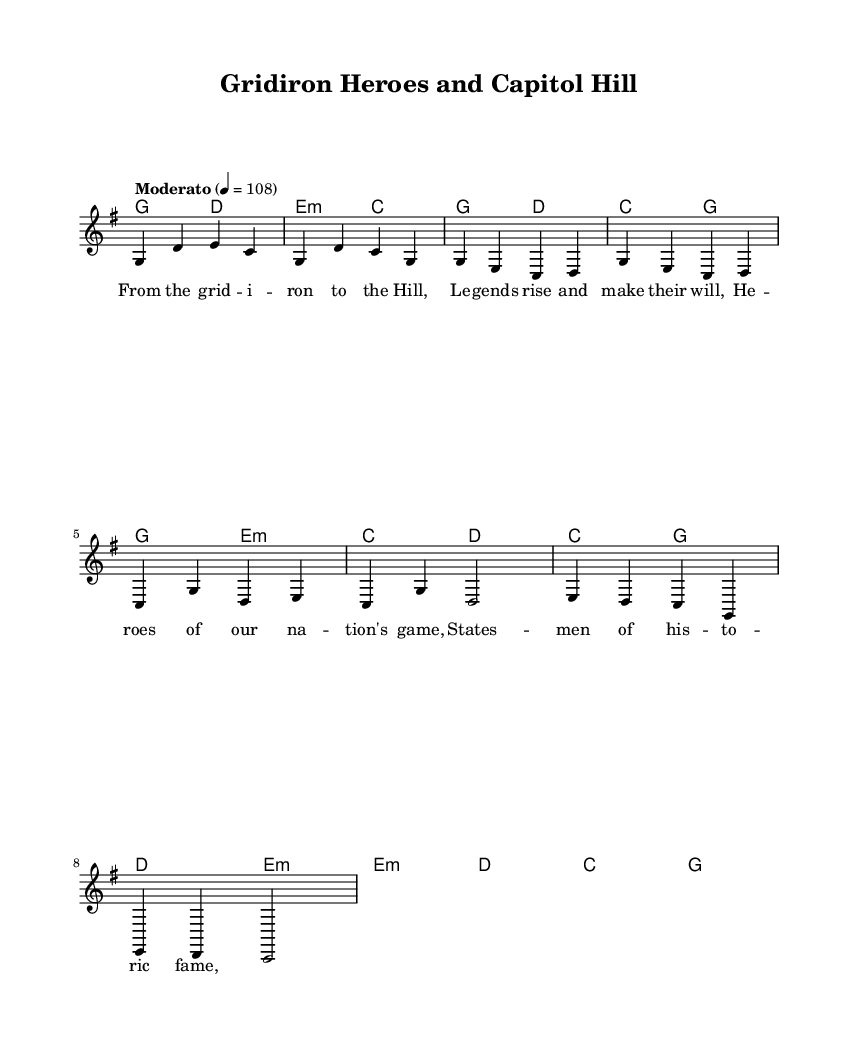What is the key signature of this music? The key signature indicated in the music is G major, which has one sharp.
Answer: G major What is the time signature of this music? The time signature shown in the score is 4/4, meaning there are four beats per measure.
Answer: 4/4 What is the tempo marking for the piece? The tempo marking is "Moderato," which suggests a moderately fast tempo, typically around 98-108 beats per minute.
Answer: Moderato How many measures are in the introductory section? The introduction consists of four measures as indicated by the notation.
Answer: 4 What type of harmony is used in the chorus section? The harmony in the chorus utilizes major and minor chords, specifically G major and E minor, which contribute to the folk-rock sound.
Answer: Major and minor What two themes are represented in the lyrics? The lyrics commemorate historical political figures and celebrate American football legends, intertwining national pride with sports.
Answer: Political figures and football legends In what style does this piece combine elements? This piece combines elements of folk-rock and patriotic themes, reflecting American culture through music and storytelling.
Answer: Folk-rock and patriotic 